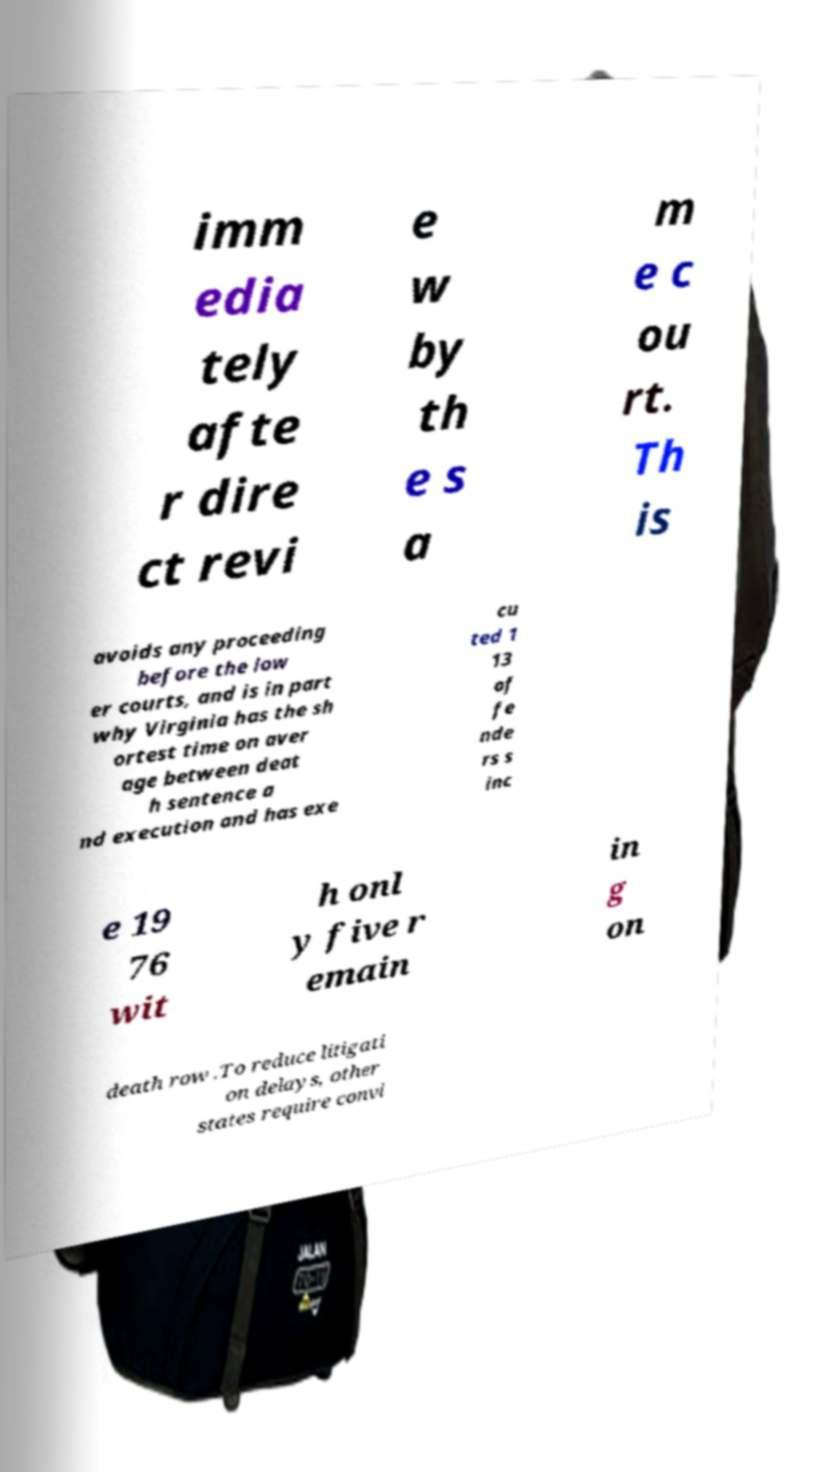Could you assist in decoding the text presented in this image and type it out clearly? imm edia tely afte r dire ct revi e w by th e s a m e c ou rt. Th is avoids any proceeding before the low er courts, and is in part why Virginia has the sh ortest time on aver age between deat h sentence a nd execution and has exe cu ted 1 13 of fe nde rs s inc e 19 76 wit h onl y five r emain in g on death row .To reduce litigati on delays, other states require convi 